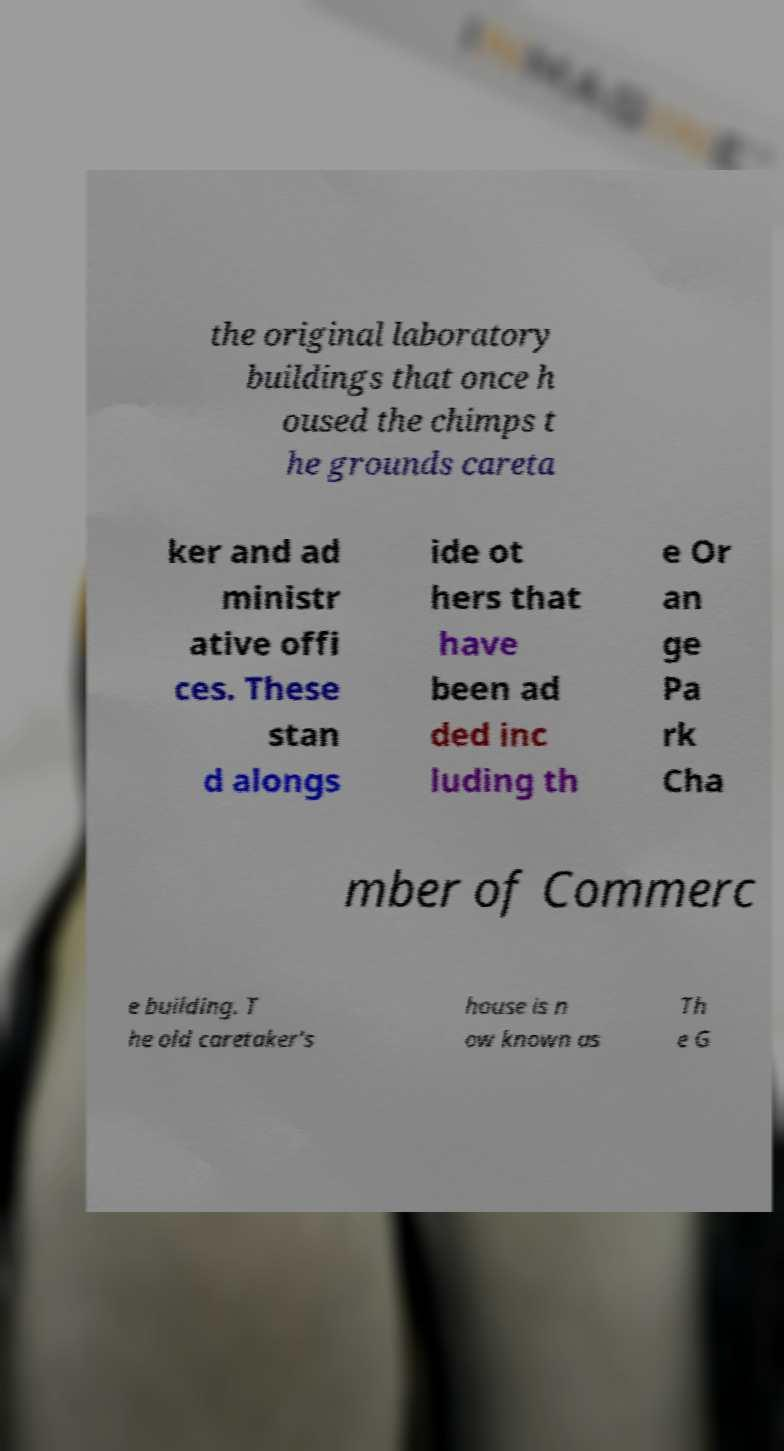Please identify and transcribe the text found in this image. the original laboratory buildings that once h oused the chimps t he grounds careta ker and ad ministr ative offi ces. These stan d alongs ide ot hers that have been ad ded inc luding th e Or an ge Pa rk Cha mber of Commerc e building. T he old caretaker's house is n ow known as Th e G 